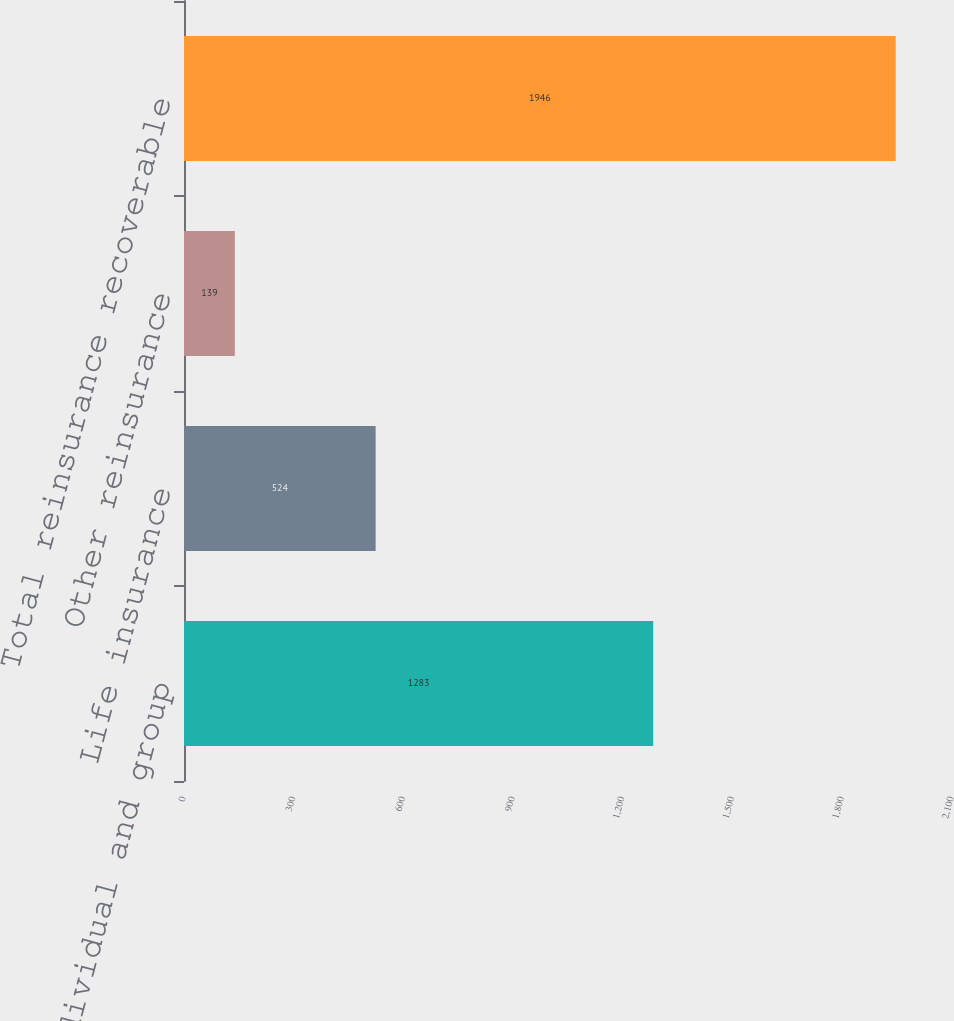<chart> <loc_0><loc_0><loc_500><loc_500><bar_chart><fcel>Individual and group<fcel>Life insurance<fcel>Other reinsurance<fcel>Total reinsurance recoverable<nl><fcel>1283<fcel>524<fcel>139<fcel>1946<nl></chart> 